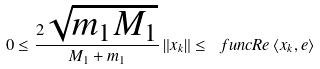<formula> <loc_0><loc_0><loc_500><loc_500>0 \leq \frac { 2 \sqrt { m _ { 1 } M _ { 1 } } } { M _ { 1 } + m _ { 1 } } \left \| x _ { k } \right \| \leq \ f u n c { R e } \left \langle x _ { k } , e \right \rangle</formula> 